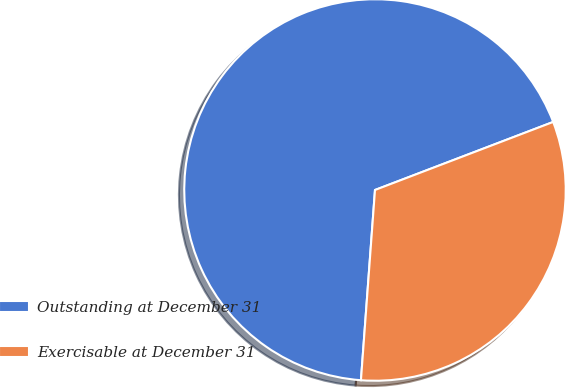Convert chart. <chart><loc_0><loc_0><loc_500><loc_500><pie_chart><fcel>Outstanding at December 31<fcel>Exercisable at December 31<nl><fcel>68.02%<fcel>31.98%<nl></chart> 